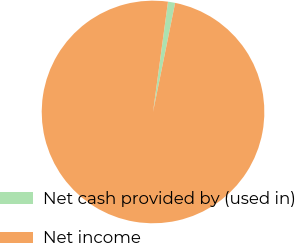Convert chart. <chart><loc_0><loc_0><loc_500><loc_500><pie_chart><fcel>Net cash provided by (used in)<fcel>Net income<nl><fcel>1.04%<fcel>98.96%<nl></chart> 